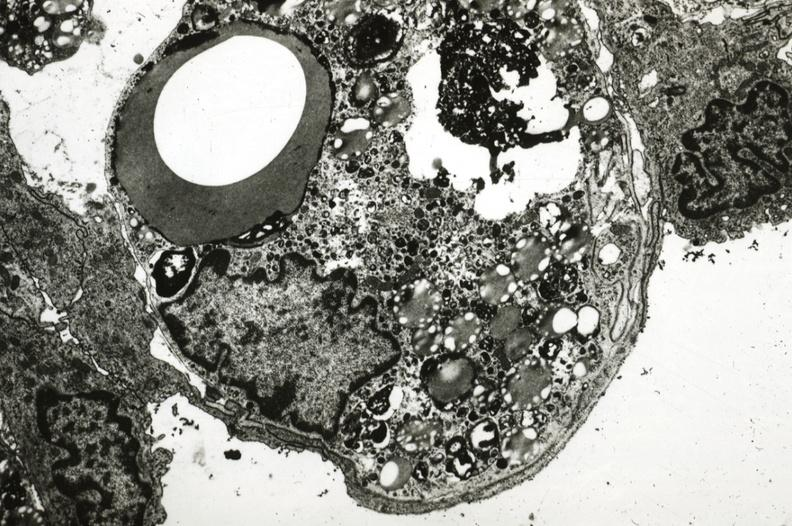what does this image show?
Answer the question using a single word or phrase. Rabbit lesion with foam cell immediately beneath endothelium 